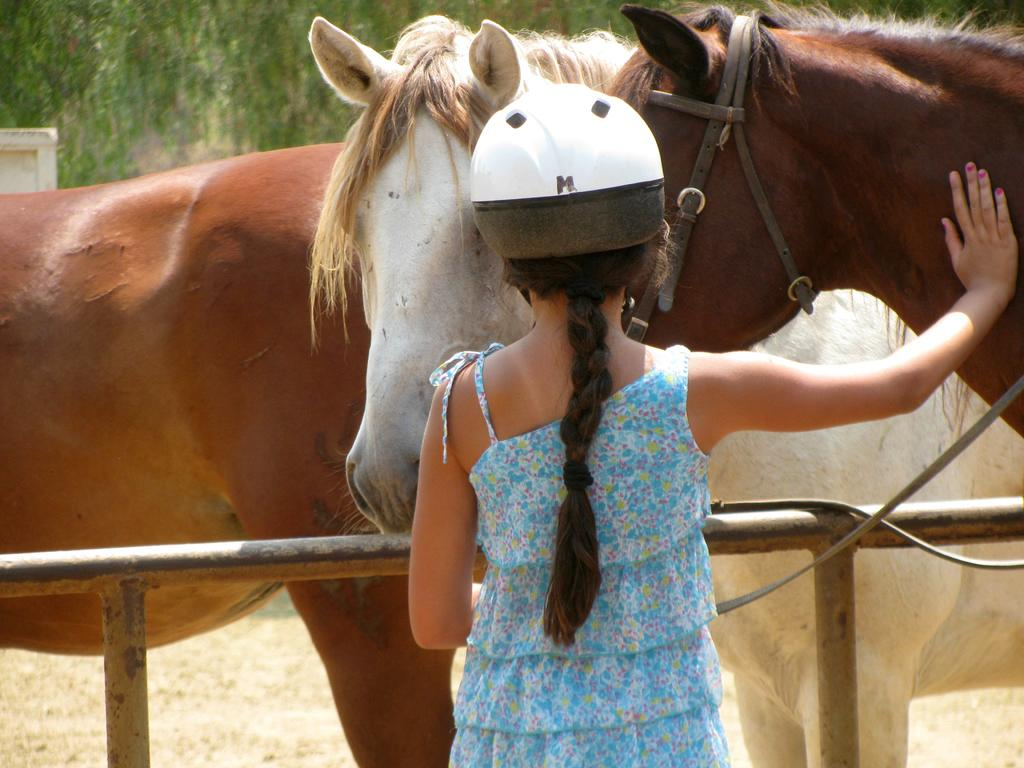Who is the main subject in the image? There is a girl in the image. What is the girl wearing on her head? The girl is wearing a helmet. What animals are in front of the girl? There are horses in front of the girl. What can be seen in the background of the image? There are trees visible in the distance. What type of flag is being waved by the queen in the image? There is no queen or flag present in the image; it features a girl with horses and trees in the background. 